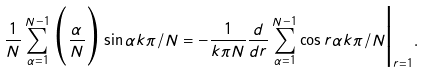Convert formula to latex. <formula><loc_0><loc_0><loc_500><loc_500>\frac { 1 } { N } \sum _ { \alpha = 1 } ^ { N - 1 } \Big ( \frac { \alpha } { N } \Big ) \sin \alpha k \pi / N = - \frac { 1 } { k \pi N } \frac { d } { d r } \sum _ { \alpha = 1 } ^ { N - 1 } \cos r \alpha k \pi / N \Big | _ { r = 1 } .</formula> 